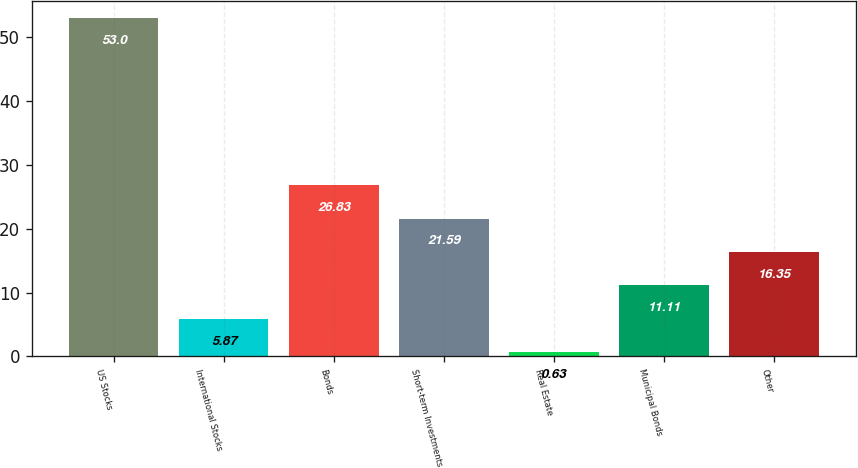<chart> <loc_0><loc_0><loc_500><loc_500><bar_chart><fcel>US Stocks<fcel>International Stocks<fcel>Bonds<fcel>Short-term Investments<fcel>Real Estate<fcel>Municipal Bonds<fcel>Other<nl><fcel>53<fcel>5.87<fcel>26.83<fcel>21.59<fcel>0.63<fcel>11.11<fcel>16.35<nl></chart> 